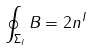Convert formula to latex. <formula><loc_0><loc_0><loc_500><loc_500>\oint _ { \Sigma _ { I } } B = 2 n ^ { I }</formula> 